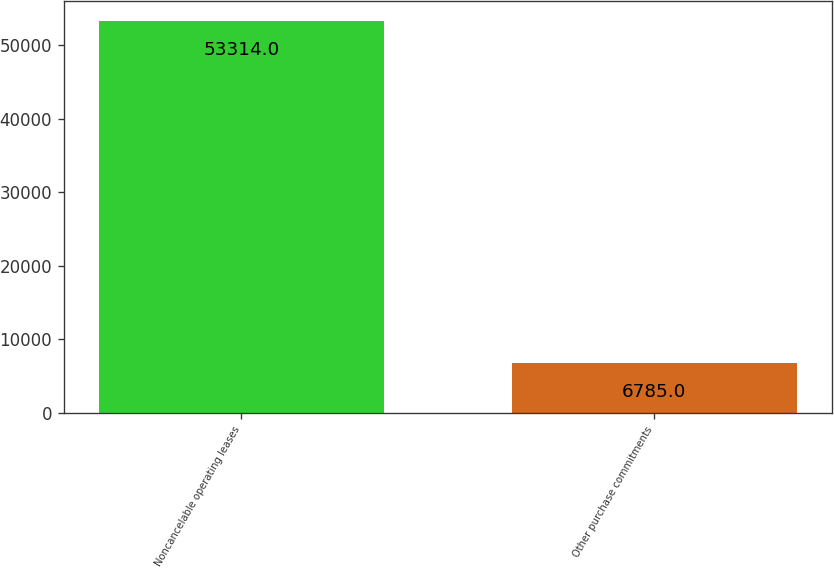Convert chart to OTSL. <chart><loc_0><loc_0><loc_500><loc_500><bar_chart><fcel>Noncancelable operating leases<fcel>Other purchase commitments<nl><fcel>53314<fcel>6785<nl></chart> 